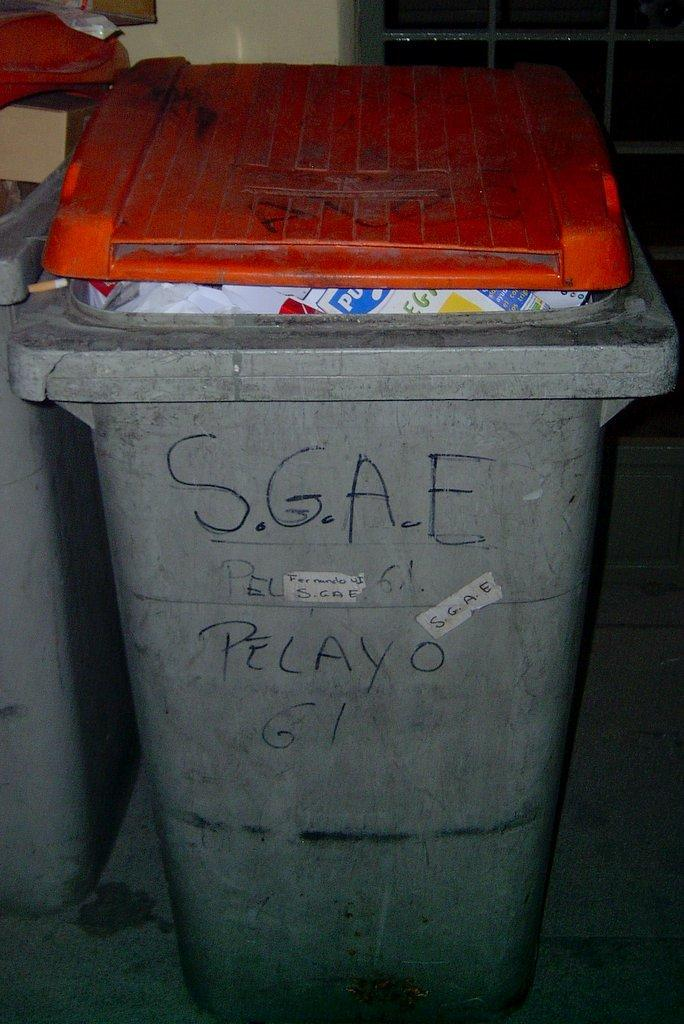<image>
Summarize the visual content of the image. SGAE Pelaxo written on a trash bin in marker 